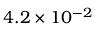Convert formula to latex. <formula><loc_0><loc_0><loc_500><loc_500>4 . 2 \times 1 0 ^ { - 2 }</formula> 